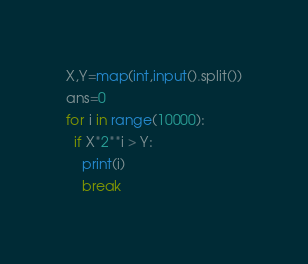Convert code to text. <code><loc_0><loc_0><loc_500><loc_500><_Python_>X,Y=map(int,input().split())
ans=0
for i in range(10000):
  if X*2**i > Y:
    print(i)
    break</code> 